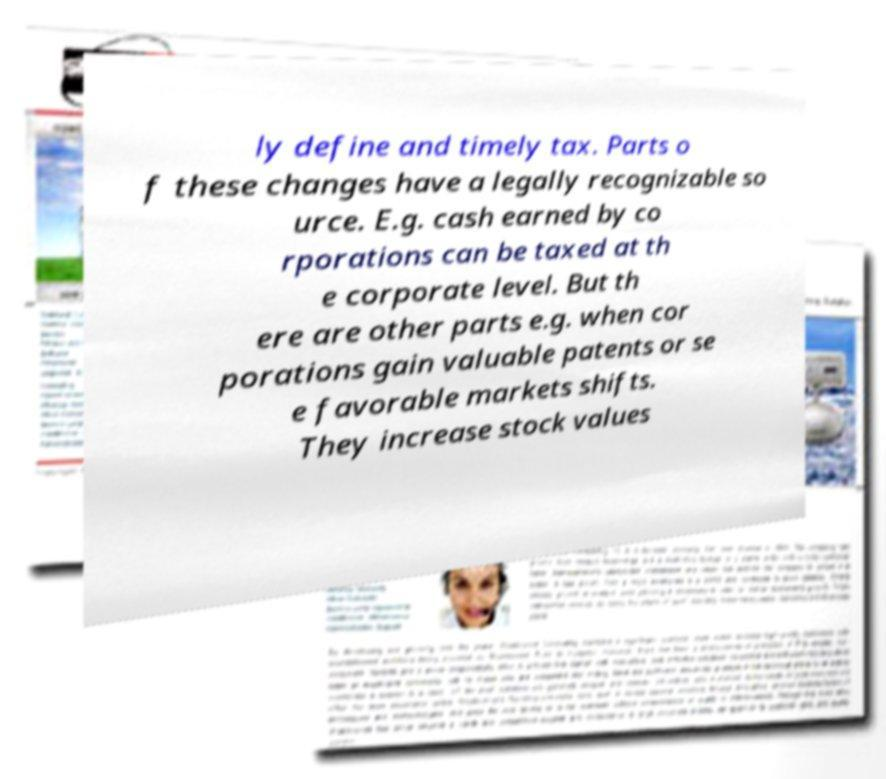For documentation purposes, I need the text within this image transcribed. Could you provide that? ly define and timely tax. Parts o f these changes have a legally recognizable so urce. E.g. cash earned by co rporations can be taxed at th e corporate level. But th ere are other parts e.g. when cor porations gain valuable patents or se e favorable markets shifts. They increase stock values 